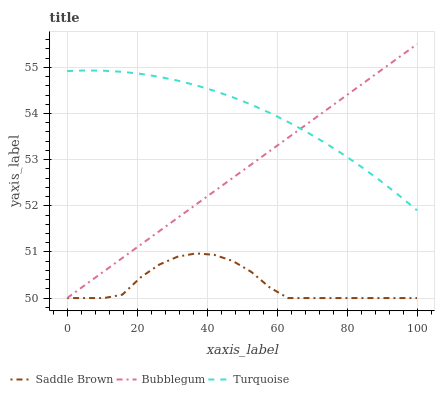Does Saddle Brown have the minimum area under the curve?
Answer yes or no. Yes. Does Turquoise have the maximum area under the curve?
Answer yes or no. Yes. Does Bubblegum have the minimum area under the curve?
Answer yes or no. No. Does Bubblegum have the maximum area under the curve?
Answer yes or no. No. Is Bubblegum the smoothest?
Answer yes or no. Yes. Is Saddle Brown the roughest?
Answer yes or no. Yes. Is Saddle Brown the smoothest?
Answer yes or no. No. Is Bubblegum the roughest?
Answer yes or no. No. Does Saddle Brown have the lowest value?
Answer yes or no. Yes. Does Bubblegum have the highest value?
Answer yes or no. Yes. Does Saddle Brown have the highest value?
Answer yes or no. No. Is Saddle Brown less than Turquoise?
Answer yes or no. Yes. Is Turquoise greater than Saddle Brown?
Answer yes or no. Yes. Does Saddle Brown intersect Bubblegum?
Answer yes or no. Yes. Is Saddle Brown less than Bubblegum?
Answer yes or no. No. Is Saddle Brown greater than Bubblegum?
Answer yes or no. No. Does Saddle Brown intersect Turquoise?
Answer yes or no. No. 